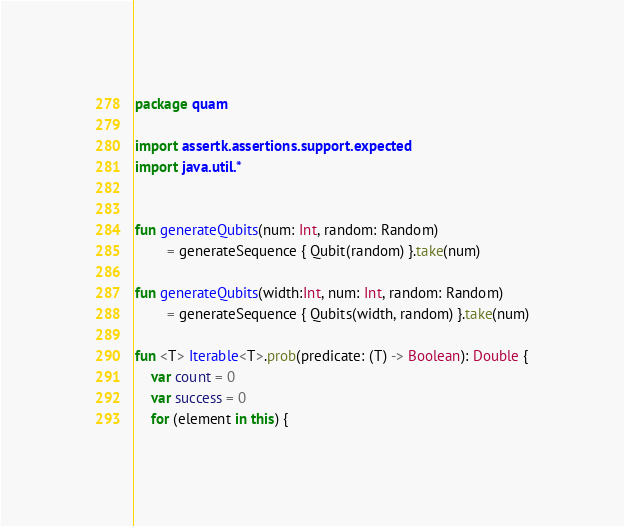<code> <loc_0><loc_0><loc_500><loc_500><_Kotlin_>package quam

import assertk.assertions.support.expected
import java.util.*


fun generateQubits(num: Int, random: Random)
        = generateSequence { Qubit(random) }.take(num)

fun generateQubits(width:Int, num: Int, random: Random)
        = generateSequence { Qubits(width, random) }.take(num)

fun <T> Iterable<T>.prob(predicate: (T) -> Boolean): Double {
    var count = 0
    var success = 0
    for (element in this) {</code> 